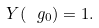Convert formula to latex. <formula><loc_0><loc_0><loc_500><loc_500>Y ( \ g _ { 0 } ) = 1 .</formula> 